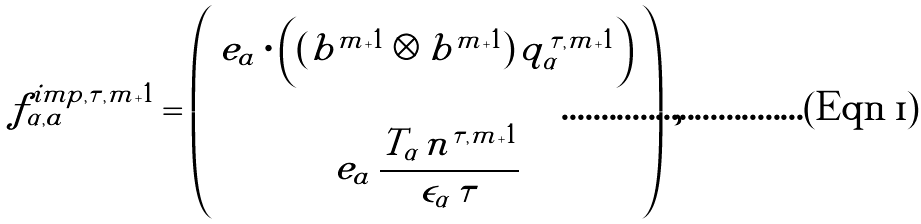Convert formula to latex. <formula><loc_0><loc_0><loc_500><loc_500>f _ { \alpha , a } ^ { i m p , \tau , m + 1 } = \left ( \begin{array} { c } e _ { a } \cdot \left ( ( b ^ { m + 1 } \otimes b ^ { m + 1 } ) \, q _ { \alpha } ^ { \tau , m + 1 } \right ) \\ \\ e _ { a } \, \cfrac { T _ { \alpha } \, n ^ { \tau , m + 1 } } { \epsilon _ { \alpha } \, \tau } \end{array} \right ) \, ,</formula> 